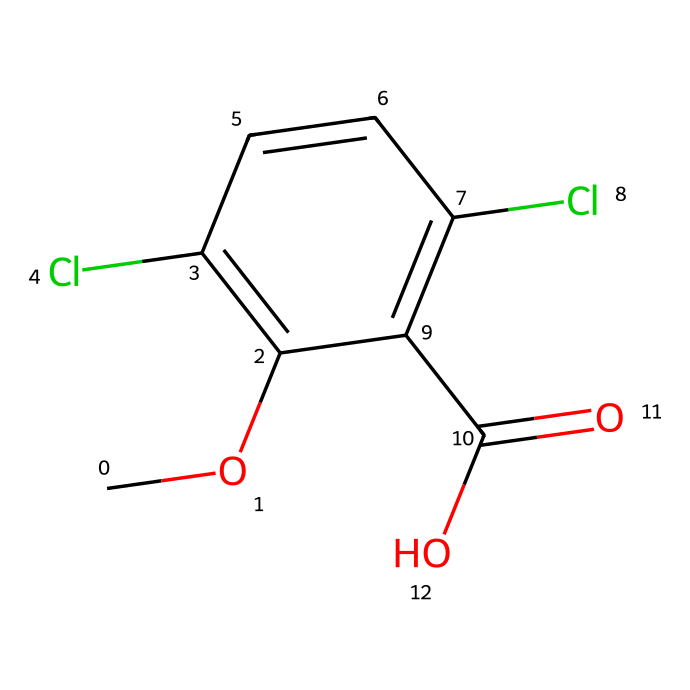What is the functional group present in dicamba? The molecular structure includes a –COOH group, which is characteristic of carboxylic acids. This indicates that dicamba contains a functional group responsible for its acidic properties.
Answer: carboxylic acid How many chlorine atoms are in dicamba? The SMILES representation shows two instances of 'Cl', indicating the presence of two chlorine atoms within the molecular structure of dicamba.
Answer: 2 What is the molecular formula derived from the given SMILES? By analyzing the SMILES, we can count the carbons (C), hydrogens (H), oxygens (O), and chlorines (Cl). The molecule contains 10 carbon atoms, 8 hydrogen atoms, 2 oxygen atoms, and 2 chlorine atoms, leading to the molecular formula C10H8Cl2O2.
Answer: C10H8Cl2O2 How many aromatic rings are in dicamba? The chemical structure displays a benzene ring, which is a common feature in herbicides, suggesting that dicamba has one aromatic ring.
Answer: 1 What is the role of chlorine in the dicamba molecule? The chlorine atoms in dicamba increase its herbicide effectiveness by enhancing the chemical's stability and possibly improving its interaction with specific biological targets.
Answer: herbicide effectiveness What type of herbicide is dicamba classified as based on its structure? The presence of a carboxylic acid group and multiple chlorine substituents places dicamba in the category of systemic herbicides, which are absorbed and translocated throughout the plant.
Answer: systemic herbicide 